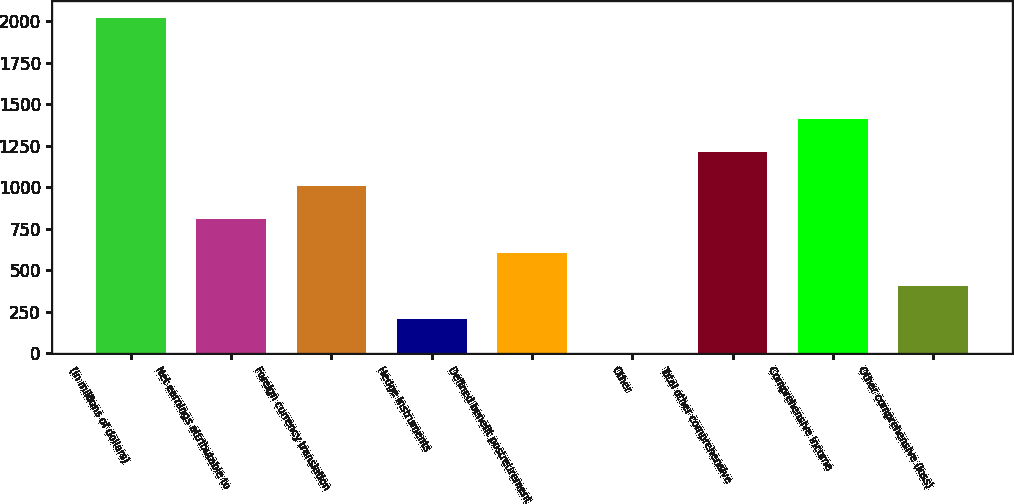Convert chart. <chart><loc_0><loc_0><loc_500><loc_500><bar_chart><fcel>(in millions of dollars)<fcel>Net earnings attributable to<fcel>Foreign currency translation<fcel>Hedge instruments<fcel>Defined benefit postretirement<fcel>Other<fcel>Total other comprehensive<fcel>Comprehensive income<fcel>Other comprehensive (loss)<nl><fcel>2018<fcel>807.86<fcel>1009.55<fcel>202.79<fcel>606.17<fcel>1.1<fcel>1211.24<fcel>1412.93<fcel>404.48<nl></chart> 